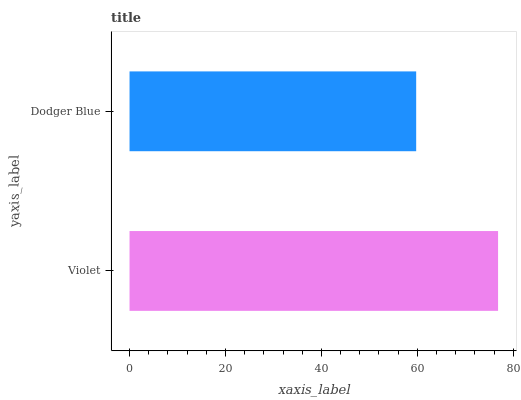Is Dodger Blue the minimum?
Answer yes or no. Yes. Is Violet the maximum?
Answer yes or no. Yes. Is Dodger Blue the maximum?
Answer yes or no. No. Is Violet greater than Dodger Blue?
Answer yes or no. Yes. Is Dodger Blue less than Violet?
Answer yes or no. Yes. Is Dodger Blue greater than Violet?
Answer yes or no. No. Is Violet less than Dodger Blue?
Answer yes or no. No. Is Violet the high median?
Answer yes or no. Yes. Is Dodger Blue the low median?
Answer yes or no. Yes. Is Dodger Blue the high median?
Answer yes or no. No. Is Violet the low median?
Answer yes or no. No. 